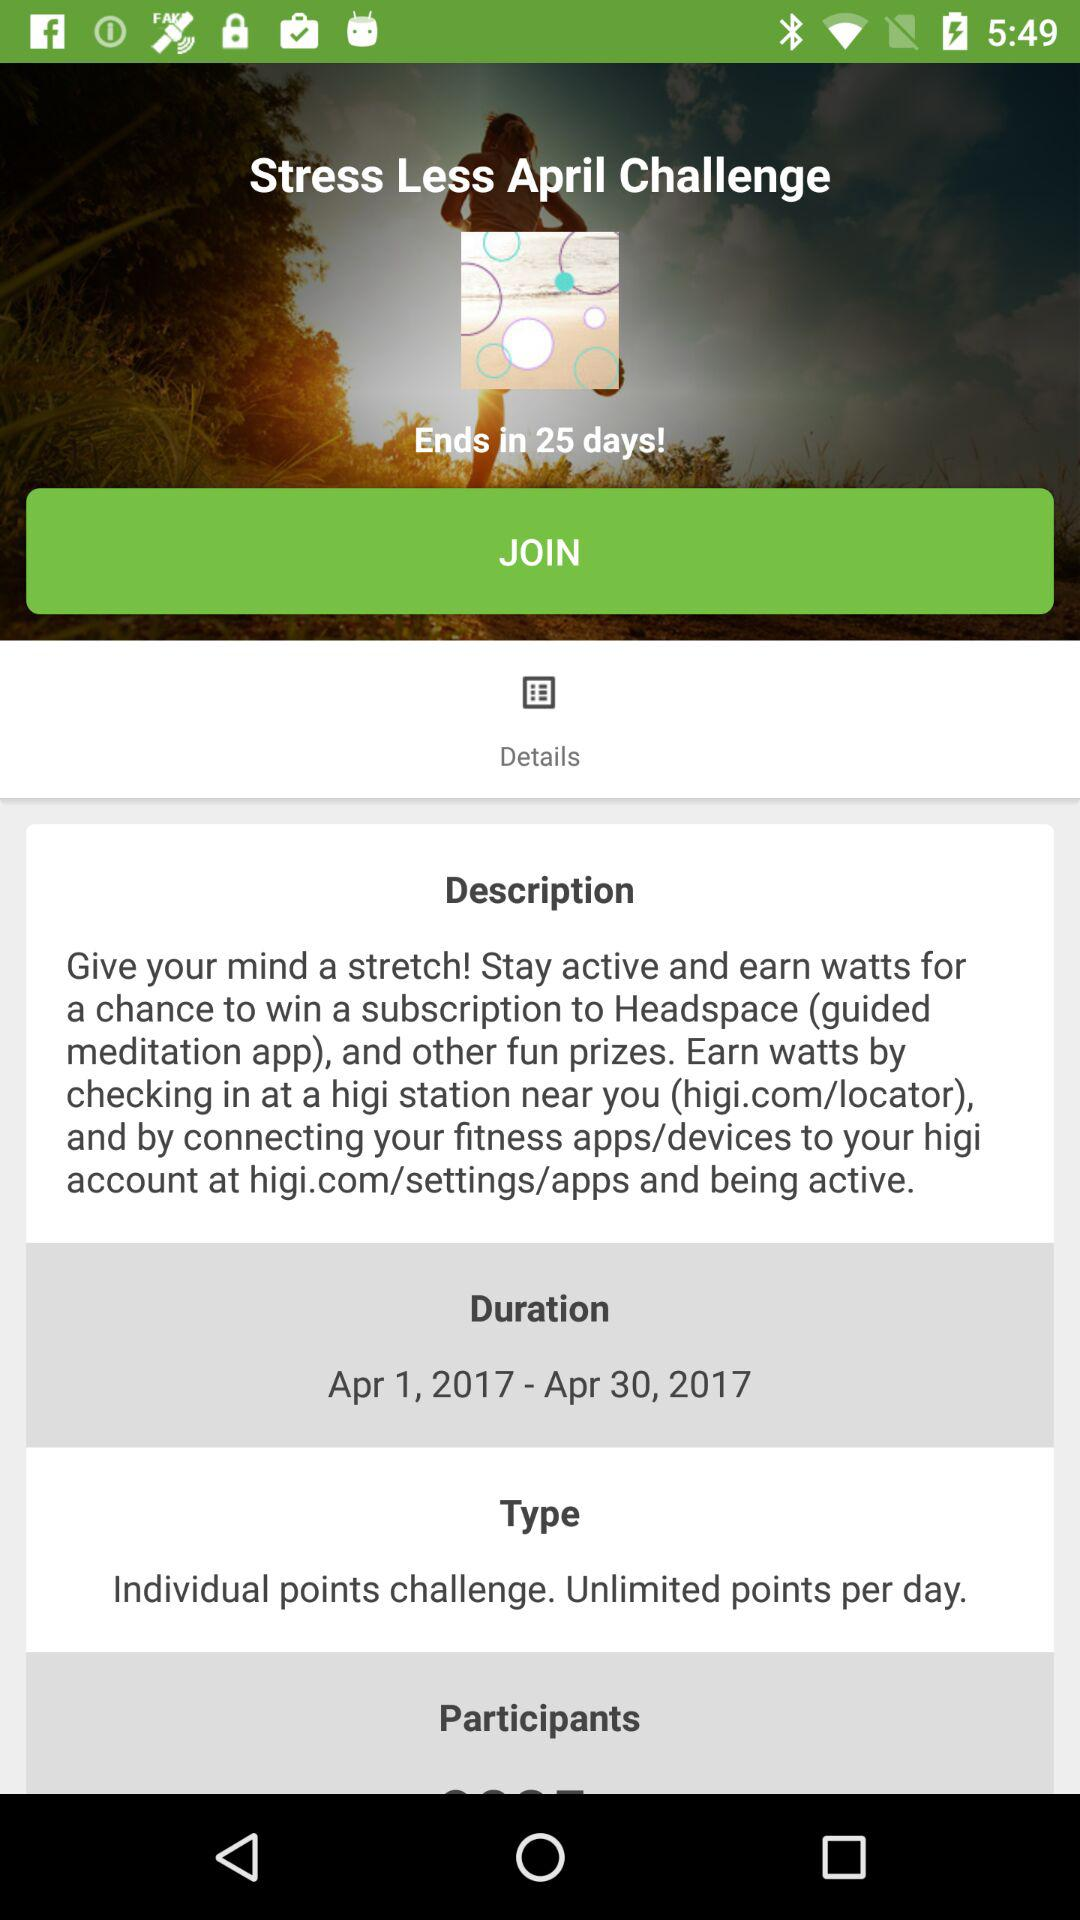In how many days will the "Stress Less April Challenge" end? The "Stress Less April Challenge" will end in 25 days. 